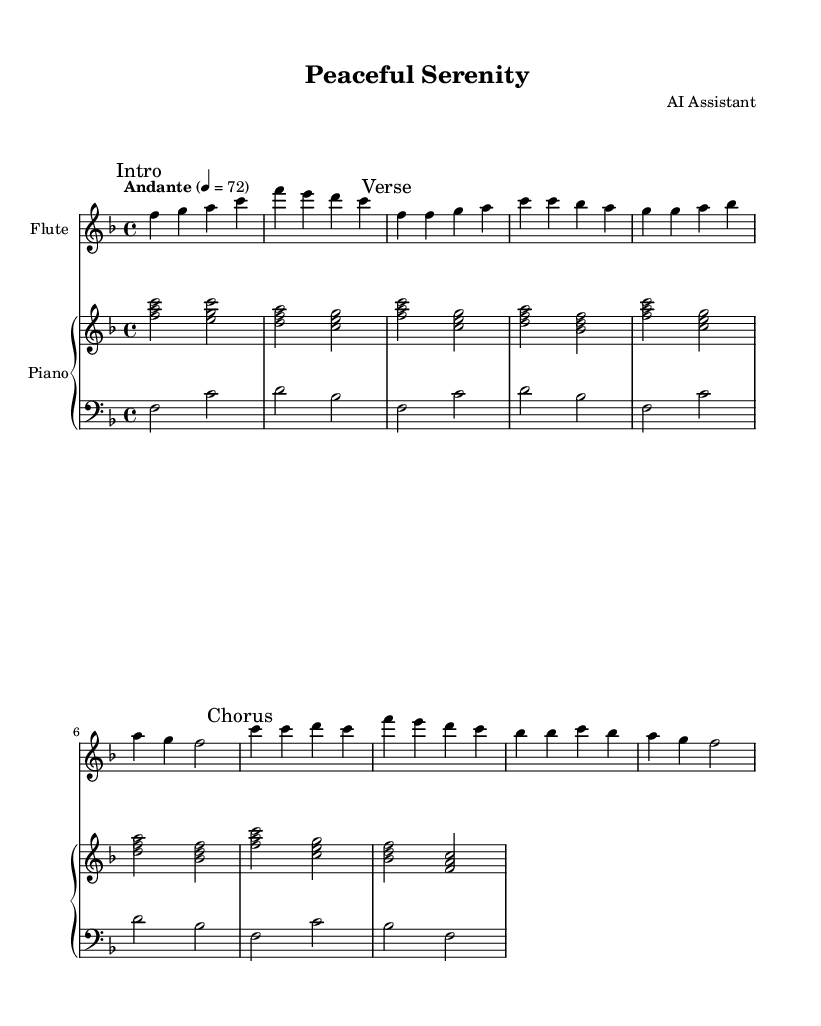What is the key signature of this music? The key signature indicated at the beginning of the music is F major, which has one flat (B flat).
Answer: F major What is the time signature of this music? The time signature shown near the beginning is 4/4, meaning there are four beats in each measure and a quarter note receives one beat.
Answer: 4/4 What is the tempo marking for this piece? The tempo marking seen in the score indicates "Andante," which typically suggests a moderate pace.
Answer: Andante How many measures are in the "Verse" section? By counting the measures from the start of the "Verse" marking to the end, there are four measures in total.
Answer: 4 Which instrument plays the melody in this piece? The melody in the score is primarily presented in the flute part, as indicated by its dedicated staff and notation.
Answer: Flute What is the overall structure of the piece? Observing the marked sections in the sheet music, the piece follows an "Intro," "Verse," and "Chorus" structure, which is typical for hymns.
Answer: Intro, Verse, Chorus Explain the relationship between the "Chorus" and "Verse" sections in terms of melody. The "Chorus" section features a variation in melody compared to the "Verse," typically being more expressive and uplifting, which is common in hymns to elevate the emotional connection.
Answer: Verse and Chorus contrast 